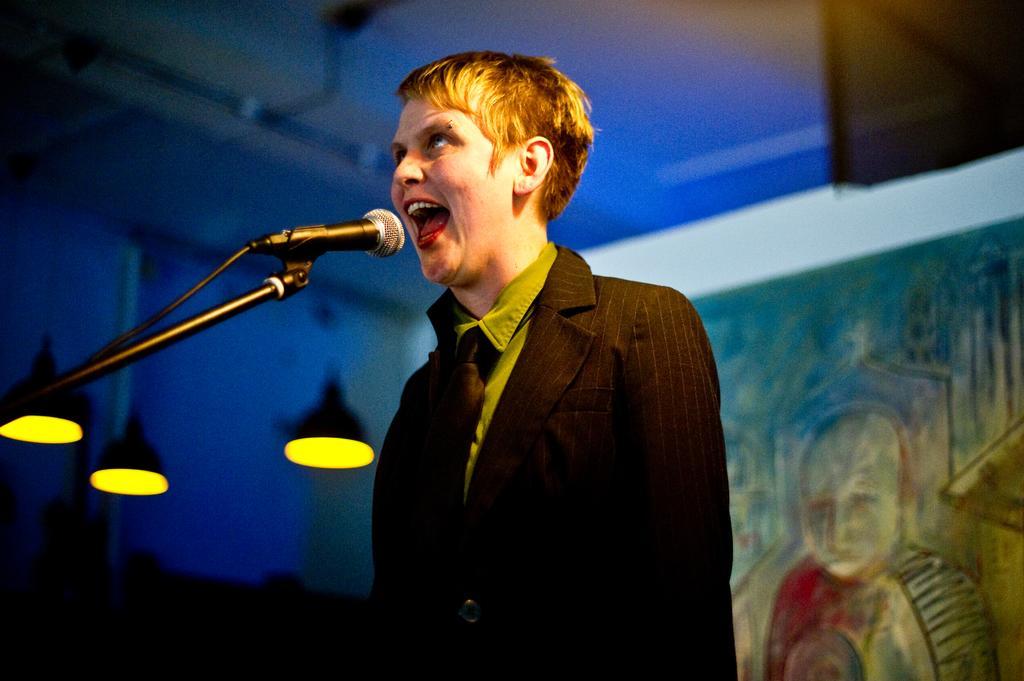How would you summarize this image in a sentence or two? In this image I can see a person. There is a mike with stand, there are lights and there is a blur background. 